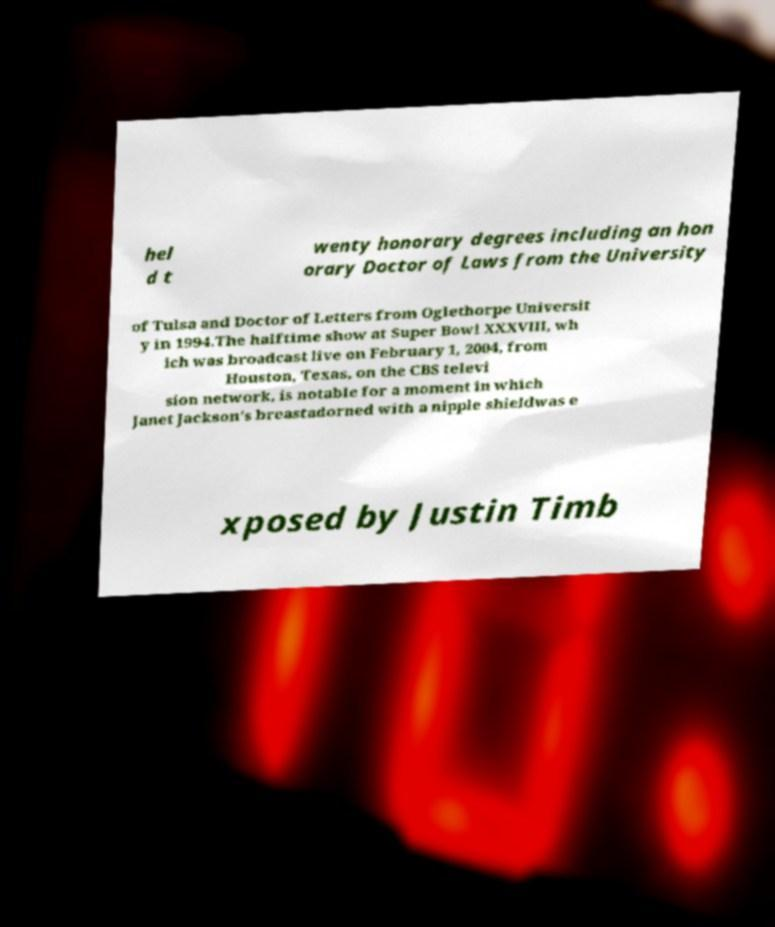I need the written content from this picture converted into text. Can you do that? hel d t wenty honorary degrees including an hon orary Doctor of Laws from the University of Tulsa and Doctor of Letters from Oglethorpe Universit y in 1994.The halftime show at Super Bowl XXXVIII, wh ich was broadcast live on February 1, 2004, from Houston, Texas, on the CBS televi sion network, is notable for a moment in which Janet Jackson's breastadorned with a nipple shieldwas e xposed by Justin Timb 